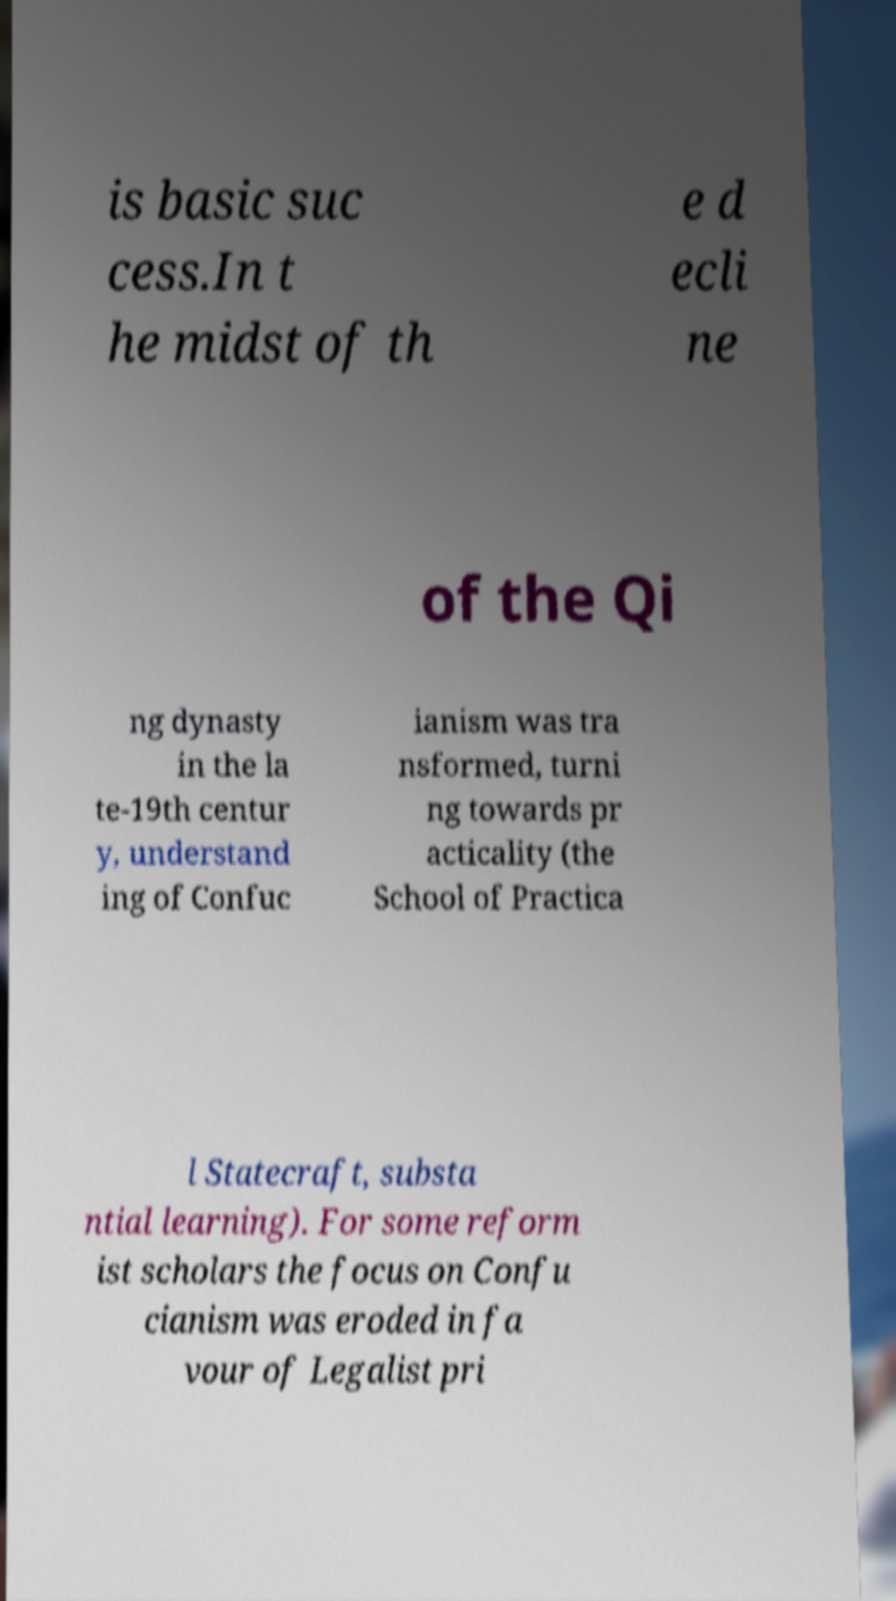What messages or text are displayed in this image? I need them in a readable, typed format. is basic suc cess.In t he midst of th e d ecli ne of the Qi ng dynasty in the la te-19th centur y, understand ing of Confuc ianism was tra nsformed, turni ng towards pr acticality (the School of Practica l Statecraft, substa ntial learning). For some reform ist scholars the focus on Confu cianism was eroded in fa vour of Legalist pri 